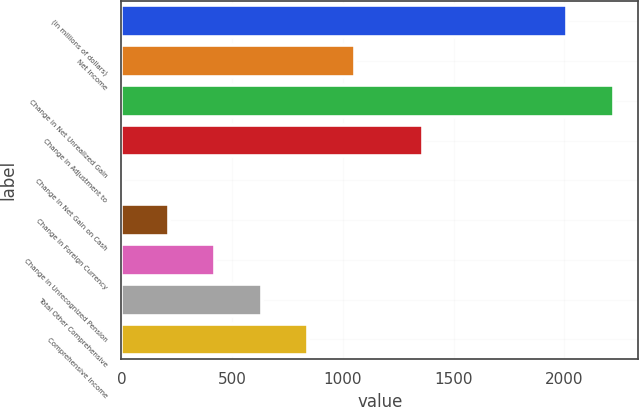<chart> <loc_0><loc_0><loc_500><loc_500><bar_chart><fcel>(in millions of dollars)<fcel>Net Income<fcel>Change in Net Unrealized Gain<fcel>Change in Adjustment to<fcel>Change in Net Gain on Cash<fcel>Change in Foreign Currency<fcel>Change in Unrecognized Pension<fcel>Total Other Comprehensive<fcel>Comprehensive Income<nl><fcel>2013<fcel>1053.25<fcel>2222.59<fcel>1363.4<fcel>5.3<fcel>214.89<fcel>424.48<fcel>634.07<fcel>843.66<nl></chart> 